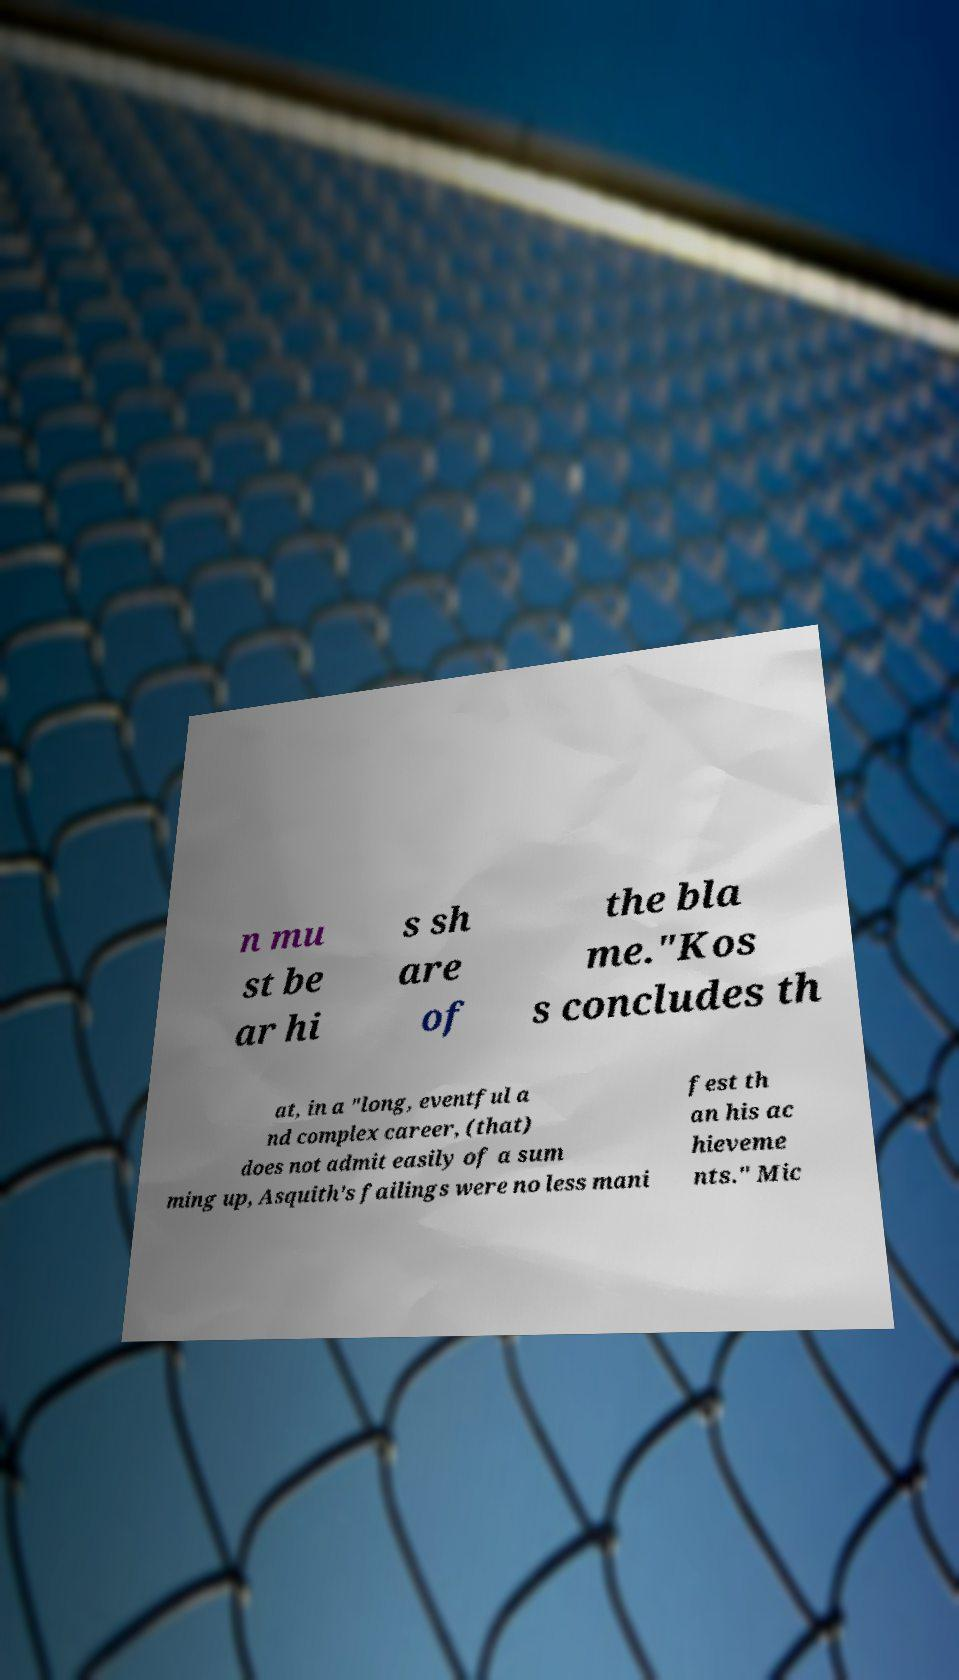I need the written content from this picture converted into text. Can you do that? n mu st be ar hi s sh are of the bla me."Kos s concludes th at, in a "long, eventful a nd complex career, (that) does not admit easily of a sum ming up, Asquith's failings were no less mani fest th an his ac hieveme nts." Mic 